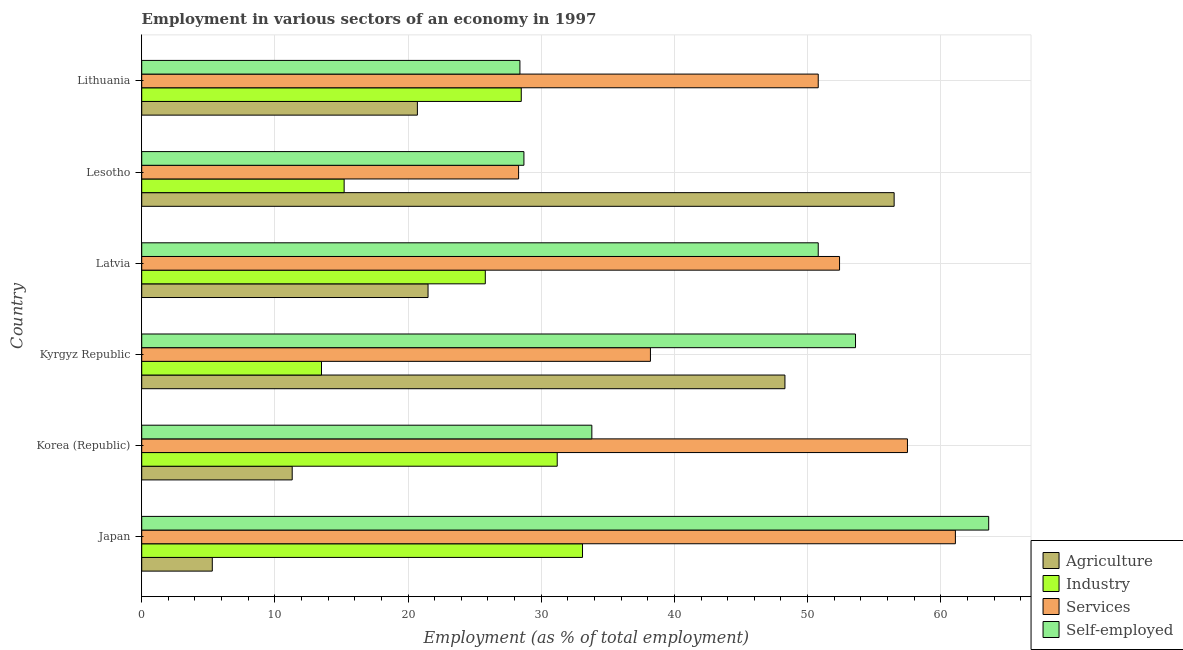How many different coloured bars are there?
Your answer should be very brief. 4. How many groups of bars are there?
Offer a very short reply. 6. Are the number of bars per tick equal to the number of legend labels?
Provide a short and direct response. Yes. Are the number of bars on each tick of the Y-axis equal?
Ensure brevity in your answer.  Yes. How many bars are there on the 6th tick from the top?
Ensure brevity in your answer.  4. What is the label of the 3rd group of bars from the top?
Your answer should be compact. Latvia. What is the percentage of self employed workers in Kyrgyz Republic?
Ensure brevity in your answer.  53.6. Across all countries, what is the maximum percentage of workers in services?
Your answer should be compact. 61.1. Across all countries, what is the minimum percentage of workers in agriculture?
Ensure brevity in your answer.  5.3. In which country was the percentage of self employed workers minimum?
Your answer should be very brief. Lithuania. What is the total percentage of workers in industry in the graph?
Ensure brevity in your answer.  147.3. What is the difference between the percentage of workers in industry in Japan and that in Kyrgyz Republic?
Ensure brevity in your answer.  19.6. What is the difference between the percentage of self employed workers in Lithuania and the percentage of workers in agriculture in Lesotho?
Give a very brief answer. -28.1. What is the average percentage of workers in agriculture per country?
Make the answer very short. 27.27. What is the difference between the percentage of workers in industry and percentage of self employed workers in Latvia?
Make the answer very short. -25. What is the ratio of the percentage of workers in industry in Latvia to that in Lithuania?
Offer a very short reply. 0.91. What is the difference between the highest and the lowest percentage of self employed workers?
Keep it short and to the point. 35.2. Is the sum of the percentage of workers in agriculture in Korea (Republic) and Kyrgyz Republic greater than the maximum percentage of workers in industry across all countries?
Offer a terse response. Yes. What does the 3rd bar from the top in Japan represents?
Your answer should be very brief. Industry. What does the 2nd bar from the bottom in Latvia represents?
Offer a terse response. Industry. Is it the case that in every country, the sum of the percentage of workers in agriculture and percentage of workers in industry is greater than the percentage of workers in services?
Ensure brevity in your answer.  No. How many bars are there?
Your response must be concise. 24. Are all the bars in the graph horizontal?
Offer a very short reply. Yes. How many countries are there in the graph?
Your answer should be compact. 6. Are the values on the major ticks of X-axis written in scientific E-notation?
Your response must be concise. No. Does the graph contain any zero values?
Ensure brevity in your answer.  No. Does the graph contain grids?
Keep it short and to the point. Yes. How many legend labels are there?
Make the answer very short. 4. How are the legend labels stacked?
Ensure brevity in your answer.  Vertical. What is the title of the graph?
Ensure brevity in your answer.  Employment in various sectors of an economy in 1997. What is the label or title of the X-axis?
Your answer should be very brief. Employment (as % of total employment). What is the label or title of the Y-axis?
Provide a succinct answer. Country. What is the Employment (as % of total employment) of Agriculture in Japan?
Give a very brief answer. 5.3. What is the Employment (as % of total employment) of Industry in Japan?
Offer a very short reply. 33.1. What is the Employment (as % of total employment) of Services in Japan?
Give a very brief answer. 61.1. What is the Employment (as % of total employment) in Self-employed in Japan?
Provide a succinct answer. 63.6. What is the Employment (as % of total employment) of Agriculture in Korea (Republic)?
Your answer should be very brief. 11.3. What is the Employment (as % of total employment) of Industry in Korea (Republic)?
Offer a terse response. 31.2. What is the Employment (as % of total employment) of Services in Korea (Republic)?
Make the answer very short. 57.5. What is the Employment (as % of total employment) of Self-employed in Korea (Republic)?
Give a very brief answer. 33.8. What is the Employment (as % of total employment) in Agriculture in Kyrgyz Republic?
Provide a short and direct response. 48.3. What is the Employment (as % of total employment) in Services in Kyrgyz Republic?
Your answer should be very brief. 38.2. What is the Employment (as % of total employment) in Self-employed in Kyrgyz Republic?
Offer a terse response. 53.6. What is the Employment (as % of total employment) of Agriculture in Latvia?
Ensure brevity in your answer.  21.5. What is the Employment (as % of total employment) of Industry in Latvia?
Give a very brief answer. 25.8. What is the Employment (as % of total employment) in Services in Latvia?
Keep it short and to the point. 52.4. What is the Employment (as % of total employment) of Self-employed in Latvia?
Offer a very short reply. 50.8. What is the Employment (as % of total employment) of Agriculture in Lesotho?
Provide a short and direct response. 56.5. What is the Employment (as % of total employment) of Industry in Lesotho?
Your response must be concise. 15.2. What is the Employment (as % of total employment) of Services in Lesotho?
Your answer should be very brief. 28.3. What is the Employment (as % of total employment) of Self-employed in Lesotho?
Ensure brevity in your answer.  28.7. What is the Employment (as % of total employment) in Agriculture in Lithuania?
Ensure brevity in your answer.  20.7. What is the Employment (as % of total employment) of Industry in Lithuania?
Your answer should be compact. 28.5. What is the Employment (as % of total employment) in Services in Lithuania?
Your answer should be compact. 50.8. What is the Employment (as % of total employment) of Self-employed in Lithuania?
Make the answer very short. 28.4. Across all countries, what is the maximum Employment (as % of total employment) of Agriculture?
Your answer should be compact. 56.5. Across all countries, what is the maximum Employment (as % of total employment) of Industry?
Make the answer very short. 33.1. Across all countries, what is the maximum Employment (as % of total employment) of Services?
Offer a terse response. 61.1. Across all countries, what is the maximum Employment (as % of total employment) of Self-employed?
Offer a very short reply. 63.6. Across all countries, what is the minimum Employment (as % of total employment) in Agriculture?
Your response must be concise. 5.3. Across all countries, what is the minimum Employment (as % of total employment) of Industry?
Ensure brevity in your answer.  13.5. Across all countries, what is the minimum Employment (as % of total employment) of Services?
Your answer should be very brief. 28.3. Across all countries, what is the minimum Employment (as % of total employment) in Self-employed?
Provide a short and direct response. 28.4. What is the total Employment (as % of total employment) in Agriculture in the graph?
Provide a succinct answer. 163.6. What is the total Employment (as % of total employment) in Industry in the graph?
Provide a succinct answer. 147.3. What is the total Employment (as % of total employment) in Services in the graph?
Provide a short and direct response. 288.3. What is the total Employment (as % of total employment) of Self-employed in the graph?
Make the answer very short. 258.9. What is the difference between the Employment (as % of total employment) of Agriculture in Japan and that in Korea (Republic)?
Give a very brief answer. -6. What is the difference between the Employment (as % of total employment) of Self-employed in Japan and that in Korea (Republic)?
Offer a terse response. 29.8. What is the difference between the Employment (as % of total employment) in Agriculture in Japan and that in Kyrgyz Republic?
Keep it short and to the point. -43. What is the difference between the Employment (as % of total employment) of Industry in Japan and that in Kyrgyz Republic?
Keep it short and to the point. 19.6. What is the difference between the Employment (as % of total employment) of Services in Japan and that in Kyrgyz Republic?
Ensure brevity in your answer.  22.9. What is the difference between the Employment (as % of total employment) in Self-employed in Japan and that in Kyrgyz Republic?
Offer a very short reply. 10. What is the difference between the Employment (as % of total employment) of Agriculture in Japan and that in Latvia?
Offer a very short reply. -16.2. What is the difference between the Employment (as % of total employment) of Industry in Japan and that in Latvia?
Offer a very short reply. 7.3. What is the difference between the Employment (as % of total employment) of Agriculture in Japan and that in Lesotho?
Make the answer very short. -51.2. What is the difference between the Employment (as % of total employment) in Services in Japan and that in Lesotho?
Your response must be concise. 32.8. What is the difference between the Employment (as % of total employment) in Self-employed in Japan and that in Lesotho?
Your response must be concise. 34.9. What is the difference between the Employment (as % of total employment) of Agriculture in Japan and that in Lithuania?
Your answer should be very brief. -15.4. What is the difference between the Employment (as % of total employment) of Industry in Japan and that in Lithuania?
Your response must be concise. 4.6. What is the difference between the Employment (as % of total employment) of Self-employed in Japan and that in Lithuania?
Provide a succinct answer. 35.2. What is the difference between the Employment (as % of total employment) of Agriculture in Korea (Republic) and that in Kyrgyz Republic?
Provide a succinct answer. -37. What is the difference between the Employment (as % of total employment) of Services in Korea (Republic) and that in Kyrgyz Republic?
Your answer should be compact. 19.3. What is the difference between the Employment (as % of total employment) of Self-employed in Korea (Republic) and that in Kyrgyz Republic?
Your answer should be very brief. -19.8. What is the difference between the Employment (as % of total employment) in Agriculture in Korea (Republic) and that in Latvia?
Give a very brief answer. -10.2. What is the difference between the Employment (as % of total employment) in Industry in Korea (Republic) and that in Latvia?
Provide a short and direct response. 5.4. What is the difference between the Employment (as % of total employment) of Services in Korea (Republic) and that in Latvia?
Offer a very short reply. 5.1. What is the difference between the Employment (as % of total employment) of Agriculture in Korea (Republic) and that in Lesotho?
Your response must be concise. -45.2. What is the difference between the Employment (as % of total employment) in Industry in Korea (Republic) and that in Lesotho?
Offer a very short reply. 16. What is the difference between the Employment (as % of total employment) in Services in Korea (Republic) and that in Lesotho?
Your response must be concise. 29.2. What is the difference between the Employment (as % of total employment) in Services in Korea (Republic) and that in Lithuania?
Provide a succinct answer. 6.7. What is the difference between the Employment (as % of total employment) of Agriculture in Kyrgyz Republic and that in Latvia?
Your answer should be very brief. 26.8. What is the difference between the Employment (as % of total employment) of Industry in Kyrgyz Republic and that in Latvia?
Offer a very short reply. -12.3. What is the difference between the Employment (as % of total employment) of Agriculture in Kyrgyz Republic and that in Lesotho?
Your answer should be compact. -8.2. What is the difference between the Employment (as % of total employment) of Services in Kyrgyz Republic and that in Lesotho?
Make the answer very short. 9.9. What is the difference between the Employment (as % of total employment) in Self-employed in Kyrgyz Republic and that in Lesotho?
Make the answer very short. 24.9. What is the difference between the Employment (as % of total employment) in Agriculture in Kyrgyz Republic and that in Lithuania?
Offer a terse response. 27.6. What is the difference between the Employment (as % of total employment) in Services in Kyrgyz Republic and that in Lithuania?
Keep it short and to the point. -12.6. What is the difference between the Employment (as % of total employment) of Self-employed in Kyrgyz Republic and that in Lithuania?
Ensure brevity in your answer.  25.2. What is the difference between the Employment (as % of total employment) in Agriculture in Latvia and that in Lesotho?
Provide a short and direct response. -35. What is the difference between the Employment (as % of total employment) of Services in Latvia and that in Lesotho?
Your answer should be compact. 24.1. What is the difference between the Employment (as % of total employment) in Self-employed in Latvia and that in Lesotho?
Provide a short and direct response. 22.1. What is the difference between the Employment (as % of total employment) of Self-employed in Latvia and that in Lithuania?
Make the answer very short. 22.4. What is the difference between the Employment (as % of total employment) in Agriculture in Lesotho and that in Lithuania?
Give a very brief answer. 35.8. What is the difference between the Employment (as % of total employment) of Industry in Lesotho and that in Lithuania?
Your answer should be compact. -13.3. What is the difference between the Employment (as % of total employment) in Services in Lesotho and that in Lithuania?
Provide a short and direct response. -22.5. What is the difference between the Employment (as % of total employment) of Self-employed in Lesotho and that in Lithuania?
Your answer should be very brief. 0.3. What is the difference between the Employment (as % of total employment) of Agriculture in Japan and the Employment (as % of total employment) of Industry in Korea (Republic)?
Give a very brief answer. -25.9. What is the difference between the Employment (as % of total employment) in Agriculture in Japan and the Employment (as % of total employment) in Services in Korea (Republic)?
Keep it short and to the point. -52.2. What is the difference between the Employment (as % of total employment) of Agriculture in Japan and the Employment (as % of total employment) of Self-employed in Korea (Republic)?
Provide a short and direct response. -28.5. What is the difference between the Employment (as % of total employment) of Industry in Japan and the Employment (as % of total employment) of Services in Korea (Republic)?
Your answer should be very brief. -24.4. What is the difference between the Employment (as % of total employment) of Services in Japan and the Employment (as % of total employment) of Self-employed in Korea (Republic)?
Keep it short and to the point. 27.3. What is the difference between the Employment (as % of total employment) in Agriculture in Japan and the Employment (as % of total employment) in Industry in Kyrgyz Republic?
Offer a terse response. -8.2. What is the difference between the Employment (as % of total employment) in Agriculture in Japan and the Employment (as % of total employment) in Services in Kyrgyz Republic?
Provide a short and direct response. -32.9. What is the difference between the Employment (as % of total employment) of Agriculture in Japan and the Employment (as % of total employment) of Self-employed in Kyrgyz Republic?
Your answer should be compact. -48.3. What is the difference between the Employment (as % of total employment) in Industry in Japan and the Employment (as % of total employment) in Self-employed in Kyrgyz Republic?
Your response must be concise. -20.5. What is the difference between the Employment (as % of total employment) of Agriculture in Japan and the Employment (as % of total employment) of Industry in Latvia?
Provide a succinct answer. -20.5. What is the difference between the Employment (as % of total employment) of Agriculture in Japan and the Employment (as % of total employment) of Services in Latvia?
Offer a terse response. -47.1. What is the difference between the Employment (as % of total employment) of Agriculture in Japan and the Employment (as % of total employment) of Self-employed in Latvia?
Make the answer very short. -45.5. What is the difference between the Employment (as % of total employment) of Industry in Japan and the Employment (as % of total employment) of Services in Latvia?
Offer a very short reply. -19.3. What is the difference between the Employment (as % of total employment) of Industry in Japan and the Employment (as % of total employment) of Self-employed in Latvia?
Ensure brevity in your answer.  -17.7. What is the difference between the Employment (as % of total employment) of Agriculture in Japan and the Employment (as % of total employment) of Services in Lesotho?
Make the answer very short. -23. What is the difference between the Employment (as % of total employment) in Agriculture in Japan and the Employment (as % of total employment) in Self-employed in Lesotho?
Ensure brevity in your answer.  -23.4. What is the difference between the Employment (as % of total employment) in Industry in Japan and the Employment (as % of total employment) in Self-employed in Lesotho?
Provide a succinct answer. 4.4. What is the difference between the Employment (as % of total employment) of Services in Japan and the Employment (as % of total employment) of Self-employed in Lesotho?
Provide a short and direct response. 32.4. What is the difference between the Employment (as % of total employment) in Agriculture in Japan and the Employment (as % of total employment) in Industry in Lithuania?
Offer a terse response. -23.2. What is the difference between the Employment (as % of total employment) in Agriculture in Japan and the Employment (as % of total employment) in Services in Lithuania?
Your answer should be compact. -45.5. What is the difference between the Employment (as % of total employment) in Agriculture in Japan and the Employment (as % of total employment) in Self-employed in Lithuania?
Offer a terse response. -23.1. What is the difference between the Employment (as % of total employment) of Industry in Japan and the Employment (as % of total employment) of Services in Lithuania?
Your answer should be very brief. -17.7. What is the difference between the Employment (as % of total employment) in Industry in Japan and the Employment (as % of total employment) in Self-employed in Lithuania?
Provide a succinct answer. 4.7. What is the difference between the Employment (as % of total employment) of Services in Japan and the Employment (as % of total employment) of Self-employed in Lithuania?
Your response must be concise. 32.7. What is the difference between the Employment (as % of total employment) of Agriculture in Korea (Republic) and the Employment (as % of total employment) of Services in Kyrgyz Republic?
Provide a short and direct response. -26.9. What is the difference between the Employment (as % of total employment) in Agriculture in Korea (Republic) and the Employment (as % of total employment) in Self-employed in Kyrgyz Republic?
Your response must be concise. -42.3. What is the difference between the Employment (as % of total employment) of Industry in Korea (Republic) and the Employment (as % of total employment) of Self-employed in Kyrgyz Republic?
Provide a short and direct response. -22.4. What is the difference between the Employment (as % of total employment) of Agriculture in Korea (Republic) and the Employment (as % of total employment) of Industry in Latvia?
Offer a terse response. -14.5. What is the difference between the Employment (as % of total employment) in Agriculture in Korea (Republic) and the Employment (as % of total employment) in Services in Latvia?
Provide a succinct answer. -41.1. What is the difference between the Employment (as % of total employment) in Agriculture in Korea (Republic) and the Employment (as % of total employment) in Self-employed in Latvia?
Provide a short and direct response. -39.5. What is the difference between the Employment (as % of total employment) of Industry in Korea (Republic) and the Employment (as % of total employment) of Services in Latvia?
Ensure brevity in your answer.  -21.2. What is the difference between the Employment (as % of total employment) in Industry in Korea (Republic) and the Employment (as % of total employment) in Self-employed in Latvia?
Keep it short and to the point. -19.6. What is the difference between the Employment (as % of total employment) of Agriculture in Korea (Republic) and the Employment (as % of total employment) of Services in Lesotho?
Your answer should be compact. -17. What is the difference between the Employment (as % of total employment) in Agriculture in Korea (Republic) and the Employment (as % of total employment) in Self-employed in Lesotho?
Your answer should be very brief. -17.4. What is the difference between the Employment (as % of total employment) in Industry in Korea (Republic) and the Employment (as % of total employment) in Self-employed in Lesotho?
Your answer should be compact. 2.5. What is the difference between the Employment (as % of total employment) in Services in Korea (Republic) and the Employment (as % of total employment) in Self-employed in Lesotho?
Provide a short and direct response. 28.8. What is the difference between the Employment (as % of total employment) of Agriculture in Korea (Republic) and the Employment (as % of total employment) of Industry in Lithuania?
Your response must be concise. -17.2. What is the difference between the Employment (as % of total employment) in Agriculture in Korea (Republic) and the Employment (as % of total employment) in Services in Lithuania?
Make the answer very short. -39.5. What is the difference between the Employment (as % of total employment) in Agriculture in Korea (Republic) and the Employment (as % of total employment) in Self-employed in Lithuania?
Keep it short and to the point. -17.1. What is the difference between the Employment (as % of total employment) of Industry in Korea (Republic) and the Employment (as % of total employment) of Services in Lithuania?
Your response must be concise. -19.6. What is the difference between the Employment (as % of total employment) of Industry in Korea (Republic) and the Employment (as % of total employment) of Self-employed in Lithuania?
Provide a succinct answer. 2.8. What is the difference between the Employment (as % of total employment) in Services in Korea (Republic) and the Employment (as % of total employment) in Self-employed in Lithuania?
Provide a short and direct response. 29.1. What is the difference between the Employment (as % of total employment) of Agriculture in Kyrgyz Republic and the Employment (as % of total employment) of Industry in Latvia?
Your answer should be compact. 22.5. What is the difference between the Employment (as % of total employment) in Agriculture in Kyrgyz Republic and the Employment (as % of total employment) in Self-employed in Latvia?
Make the answer very short. -2.5. What is the difference between the Employment (as % of total employment) of Industry in Kyrgyz Republic and the Employment (as % of total employment) of Services in Latvia?
Give a very brief answer. -38.9. What is the difference between the Employment (as % of total employment) of Industry in Kyrgyz Republic and the Employment (as % of total employment) of Self-employed in Latvia?
Provide a succinct answer. -37.3. What is the difference between the Employment (as % of total employment) of Agriculture in Kyrgyz Republic and the Employment (as % of total employment) of Industry in Lesotho?
Make the answer very short. 33.1. What is the difference between the Employment (as % of total employment) in Agriculture in Kyrgyz Republic and the Employment (as % of total employment) in Self-employed in Lesotho?
Your response must be concise. 19.6. What is the difference between the Employment (as % of total employment) of Industry in Kyrgyz Republic and the Employment (as % of total employment) of Services in Lesotho?
Offer a very short reply. -14.8. What is the difference between the Employment (as % of total employment) of Industry in Kyrgyz Republic and the Employment (as % of total employment) of Self-employed in Lesotho?
Your answer should be compact. -15.2. What is the difference between the Employment (as % of total employment) of Agriculture in Kyrgyz Republic and the Employment (as % of total employment) of Industry in Lithuania?
Make the answer very short. 19.8. What is the difference between the Employment (as % of total employment) of Agriculture in Kyrgyz Republic and the Employment (as % of total employment) of Services in Lithuania?
Keep it short and to the point. -2.5. What is the difference between the Employment (as % of total employment) of Agriculture in Kyrgyz Republic and the Employment (as % of total employment) of Self-employed in Lithuania?
Your answer should be very brief. 19.9. What is the difference between the Employment (as % of total employment) of Industry in Kyrgyz Republic and the Employment (as % of total employment) of Services in Lithuania?
Give a very brief answer. -37.3. What is the difference between the Employment (as % of total employment) in Industry in Kyrgyz Republic and the Employment (as % of total employment) in Self-employed in Lithuania?
Offer a very short reply. -14.9. What is the difference between the Employment (as % of total employment) in Agriculture in Latvia and the Employment (as % of total employment) in Services in Lesotho?
Provide a succinct answer. -6.8. What is the difference between the Employment (as % of total employment) of Agriculture in Latvia and the Employment (as % of total employment) of Self-employed in Lesotho?
Your answer should be compact. -7.2. What is the difference between the Employment (as % of total employment) of Industry in Latvia and the Employment (as % of total employment) of Services in Lesotho?
Your response must be concise. -2.5. What is the difference between the Employment (as % of total employment) of Industry in Latvia and the Employment (as % of total employment) of Self-employed in Lesotho?
Keep it short and to the point. -2.9. What is the difference between the Employment (as % of total employment) in Services in Latvia and the Employment (as % of total employment) in Self-employed in Lesotho?
Make the answer very short. 23.7. What is the difference between the Employment (as % of total employment) of Agriculture in Latvia and the Employment (as % of total employment) of Industry in Lithuania?
Offer a terse response. -7. What is the difference between the Employment (as % of total employment) in Agriculture in Latvia and the Employment (as % of total employment) in Services in Lithuania?
Your response must be concise. -29.3. What is the difference between the Employment (as % of total employment) in Agriculture in Latvia and the Employment (as % of total employment) in Self-employed in Lithuania?
Offer a terse response. -6.9. What is the difference between the Employment (as % of total employment) in Services in Latvia and the Employment (as % of total employment) in Self-employed in Lithuania?
Your answer should be compact. 24. What is the difference between the Employment (as % of total employment) of Agriculture in Lesotho and the Employment (as % of total employment) of Self-employed in Lithuania?
Your response must be concise. 28.1. What is the difference between the Employment (as % of total employment) in Industry in Lesotho and the Employment (as % of total employment) in Services in Lithuania?
Offer a very short reply. -35.6. What is the average Employment (as % of total employment) of Agriculture per country?
Keep it short and to the point. 27.27. What is the average Employment (as % of total employment) in Industry per country?
Offer a very short reply. 24.55. What is the average Employment (as % of total employment) of Services per country?
Give a very brief answer. 48.05. What is the average Employment (as % of total employment) in Self-employed per country?
Make the answer very short. 43.15. What is the difference between the Employment (as % of total employment) in Agriculture and Employment (as % of total employment) in Industry in Japan?
Provide a succinct answer. -27.8. What is the difference between the Employment (as % of total employment) of Agriculture and Employment (as % of total employment) of Services in Japan?
Your response must be concise. -55.8. What is the difference between the Employment (as % of total employment) in Agriculture and Employment (as % of total employment) in Self-employed in Japan?
Make the answer very short. -58.3. What is the difference between the Employment (as % of total employment) in Industry and Employment (as % of total employment) in Services in Japan?
Provide a short and direct response. -28. What is the difference between the Employment (as % of total employment) in Industry and Employment (as % of total employment) in Self-employed in Japan?
Keep it short and to the point. -30.5. What is the difference between the Employment (as % of total employment) in Services and Employment (as % of total employment) in Self-employed in Japan?
Provide a short and direct response. -2.5. What is the difference between the Employment (as % of total employment) of Agriculture and Employment (as % of total employment) of Industry in Korea (Republic)?
Keep it short and to the point. -19.9. What is the difference between the Employment (as % of total employment) of Agriculture and Employment (as % of total employment) of Services in Korea (Republic)?
Make the answer very short. -46.2. What is the difference between the Employment (as % of total employment) in Agriculture and Employment (as % of total employment) in Self-employed in Korea (Republic)?
Provide a succinct answer. -22.5. What is the difference between the Employment (as % of total employment) in Industry and Employment (as % of total employment) in Services in Korea (Republic)?
Provide a short and direct response. -26.3. What is the difference between the Employment (as % of total employment) of Industry and Employment (as % of total employment) of Self-employed in Korea (Republic)?
Your answer should be very brief. -2.6. What is the difference between the Employment (as % of total employment) of Services and Employment (as % of total employment) of Self-employed in Korea (Republic)?
Ensure brevity in your answer.  23.7. What is the difference between the Employment (as % of total employment) of Agriculture and Employment (as % of total employment) of Industry in Kyrgyz Republic?
Provide a short and direct response. 34.8. What is the difference between the Employment (as % of total employment) in Agriculture and Employment (as % of total employment) in Services in Kyrgyz Republic?
Your answer should be compact. 10.1. What is the difference between the Employment (as % of total employment) of Industry and Employment (as % of total employment) of Services in Kyrgyz Republic?
Provide a succinct answer. -24.7. What is the difference between the Employment (as % of total employment) of Industry and Employment (as % of total employment) of Self-employed in Kyrgyz Republic?
Ensure brevity in your answer.  -40.1. What is the difference between the Employment (as % of total employment) of Services and Employment (as % of total employment) of Self-employed in Kyrgyz Republic?
Make the answer very short. -15.4. What is the difference between the Employment (as % of total employment) in Agriculture and Employment (as % of total employment) in Industry in Latvia?
Provide a succinct answer. -4.3. What is the difference between the Employment (as % of total employment) of Agriculture and Employment (as % of total employment) of Services in Latvia?
Provide a short and direct response. -30.9. What is the difference between the Employment (as % of total employment) in Agriculture and Employment (as % of total employment) in Self-employed in Latvia?
Ensure brevity in your answer.  -29.3. What is the difference between the Employment (as % of total employment) in Industry and Employment (as % of total employment) in Services in Latvia?
Make the answer very short. -26.6. What is the difference between the Employment (as % of total employment) of Industry and Employment (as % of total employment) of Self-employed in Latvia?
Provide a succinct answer. -25. What is the difference between the Employment (as % of total employment) of Agriculture and Employment (as % of total employment) of Industry in Lesotho?
Give a very brief answer. 41.3. What is the difference between the Employment (as % of total employment) of Agriculture and Employment (as % of total employment) of Services in Lesotho?
Make the answer very short. 28.2. What is the difference between the Employment (as % of total employment) in Agriculture and Employment (as % of total employment) in Self-employed in Lesotho?
Ensure brevity in your answer.  27.8. What is the difference between the Employment (as % of total employment) of Industry and Employment (as % of total employment) of Services in Lesotho?
Keep it short and to the point. -13.1. What is the difference between the Employment (as % of total employment) in Industry and Employment (as % of total employment) in Self-employed in Lesotho?
Make the answer very short. -13.5. What is the difference between the Employment (as % of total employment) of Agriculture and Employment (as % of total employment) of Industry in Lithuania?
Provide a succinct answer. -7.8. What is the difference between the Employment (as % of total employment) of Agriculture and Employment (as % of total employment) of Services in Lithuania?
Ensure brevity in your answer.  -30.1. What is the difference between the Employment (as % of total employment) in Agriculture and Employment (as % of total employment) in Self-employed in Lithuania?
Make the answer very short. -7.7. What is the difference between the Employment (as % of total employment) in Industry and Employment (as % of total employment) in Services in Lithuania?
Provide a short and direct response. -22.3. What is the difference between the Employment (as % of total employment) in Industry and Employment (as % of total employment) in Self-employed in Lithuania?
Your response must be concise. 0.1. What is the difference between the Employment (as % of total employment) in Services and Employment (as % of total employment) in Self-employed in Lithuania?
Offer a terse response. 22.4. What is the ratio of the Employment (as % of total employment) in Agriculture in Japan to that in Korea (Republic)?
Offer a terse response. 0.47. What is the ratio of the Employment (as % of total employment) of Industry in Japan to that in Korea (Republic)?
Keep it short and to the point. 1.06. What is the ratio of the Employment (as % of total employment) of Services in Japan to that in Korea (Republic)?
Keep it short and to the point. 1.06. What is the ratio of the Employment (as % of total employment) in Self-employed in Japan to that in Korea (Republic)?
Your answer should be compact. 1.88. What is the ratio of the Employment (as % of total employment) in Agriculture in Japan to that in Kyrgyz Republic?
Provide a succinct answer. 0.11. What is the ratio of the Employment (as % of total employment) of Industry in Japan to that in Kyrgyz Republic?
Offer a very short reply. 2.45. What is the ratio of the Employment (as % of total employment) of Services in Japan to that in Kyrgyz Republic?
Make the answer very short. 1.6. What is the ratio of the Employment (as % of total employment) of Self-employed in Japan to that in Kyrgyz Republic?
Offer a terse response. 1.19. What is the ratio of the Employment (as % of total employment) of Agriculture in Japan to that in Latvia?
Offer a terse response. 0.25. What is the ratio of the Employment (as % of total employment) of Industry in Japan to that in Latvia?
Provide a short and direct response. 1.28. What is the ratio of the Employment (as % of total employment) of Services in Japan to that in Latvia?
Your answer should be compact. 1.17. What is the ratio of the Employment (as % of total employment) in Self-employed in Japan to that in Latvia?
Ensure brevity in your answer.  1.25. What is the ratio of the Employment (as % of total employment) of Agriculture in Japan to that in Lesotho?
Your response must be concise. 0.09. What is the ratio of the Employment (as % of total employment) of Industry in Japan to that in Lesotho?
Keep it short and to the point. 2.18. What is the ratio of the Employment (as % of total employment) of Services in Japan to that in Lesotho?
Offer a terse response. 2.16. What is the ratio of the Employment (as % of total employment) of Self-employed in Japan to that in Lesotho?
Keep it short and to the point. 2.22. What is the ratio of the Employment (as % of total employment) in Agriculture in Japan to that in Lithuania?
Provide a short and direct response. 0.26. What is the ratio of the Employment (as % of total employment) in Industry in Japan to that in Lithuania?
Ensure brevity in your answer.  1.16. What is the ratio of the Employment (as % of total employment) in Services in Japan to that in Lithuania?
Keep it short and to the point. 1.2. What is the ratio of the Employment (as % of total employment) in Self-employed in Japan to that in Lithuania?
Your answer should be very brief. 2.24. What is the ratio of the Employment (as % of total employment) in Agriculture in Korea (Republic) to that in Kyrgyz Republic?
Offer a very short reply. 0.23. What is the ratio of the Employment (as % of total employment) in Industry in Korea (Republic) to that in Kyrgyz Republic?
Keep it short and to the point. 2.31. What is the ratio of the Employment (as % of total employment) of Services in Korea (Republic) to that in Kyrgyz Republic?
Your answer should be very brief. 1.51. What is the ratio of the Employment (as % of total employment) in Self-employed in Korea (Republic) to that in Kyrgyz Republic?
Offer a very short reply. 0.63. What is the ratio of the Employment (as % of total employment) of Agriculture in Korea (Republic) to that in Latvia?
Give a very brief answer. 0.53. What is the ratio of the Employment (as % of total employment) in Industry in Korea (Republic) to that in Latvia?
Your answer should be very brief. 1.21. What is the ratio of the Employment (as % of total employment) in Services in Korea (Republic) to that in Latvia?
Your answer should be compact. 1.1. What is the ratio of the Employment (as % of total employment) of Self-employed in Korea (Republic) to that in Latvia?
Your response must be concise. 0.67. What is the ratio of the Employment (as % of total employment) of Agriculture in Korea (Republic) to that in Lesotho?
Your response must be concise. 0.2. What is the ratio of the Employment (as % of total employment) of Industry in Korea (Republic) to that in Lesotho?
Ensure brevity in your answer.  2.05. What is the ratio of the Employment (as % of total employment) of Services in Korea (Republic) to that in Lesotho?
Offer a terse response. 2.03. What is the ratio of the Employment (as % of total employment) in Self-employed in Korea (Republic) to that in Lesotho?
Give a very brief answer. 1.18. What is the ratio of the Employment (as % of total employment) of Agriculture in Korea (Republic) to that in Lithuania?
Offer a terse response. 0.55. What is the ratio of the Employment (as % of total employment) in Industry in Korea (Republic) to that in Lithuania?
Give a very brief answer. 1.09. What is the ratio of the Employment (as % of total employment) in Services in Korea (Republic) to that in Lithuania?
Offer a terse response. 1.13. What is the ratio of the Employment (as % of total employment) in Self-employed in Korea (Republic) to that in Lithuania?
Give a very brief answer. 1.19. What is the ratio of the Employment (as % of total employment) in Agriculture in Kyrgyz Republic to that in Latvia?
Your answer should be compact. 2.25. What is the ratio of the Employment (as % of total employment) of Industry in Kyrgyz Republic to that in Latvia?
Offer a terse response. 0.52. What is the ratio of the Employment (as % of total employment) in Services in Kyrgyz Republic to that in Latvia?
Keep it short and to the point. 0.73. What is the ratio of the Employment (as % of total employment) of Self-employed in Kyrgyz Republic to that in Latvia?
Ensure brevity in your answer.  1.06. What is the ratio of the Employment (as % of total employment) in Agriculture in Kyrgyz Republic to that in Lesotho?
Your response must be concise. 0.85. What is the ratio of the Employment (as % of total employment) in Industry in Kyrgyz Republic to that in Lesotho?
Offer a terse response. 0.89. What is the ratio of the Employment (as % of total employment) of Services in Kyrgyz Republic to that in Lesotho?
Your response must be concise. 1.35. What is the ratio of the Employment (as % of total employment) of Self-employed in Kyrgyz Republic to that in Lesotho?
Your answer should be very brief. 1.87. What is the ratio of the Employment (as % of total employment) of Agriculture in Kyrgyz Republic to that in Lithuania?
Make the answer very short. 2.33. What is the ratio of the Employment (as % of total employment) of Industry in Kyrgyz Republic to that in Lithuania?
Your answer should be compact. 0.47. What is the ratio of the Employment (as % of total employment) of Services in Kyrgyz Republic to that in Lithuania?
Your answer should be very brief. 0.75. What is the ratio of the Employment (as % of total employment) of Self-employed in Kyrgyz Republic to that in Lithuania?
Offer a terse response. 1.89. What is the ratio of the Employment (as % of total employment) in Agriculture in Latvia to that in Lesotho?
Your answer should be compact. 0.38. What is the ratio of the Employment (as % of total employment) in Industry in Latvia to that in Lesotho?
Keep it short and to the point. 1.7. What is the ratio of the Employment (as % of total employment) of Services in Latvia to that in Lesotho?
Ensure brevity in your answer.  1.85. What is the ratio of the Employment (as % of total employment) in Self-employed in Latvia to that in Lesotho?
Keep it short and to the point. 1.77. What is the ratio of the Employment (as % of total employment) of Agriculture in Latvia to that in Lithuania?
Your answer should be very brief. 1.04. What is the ratio of the Employment (as % of total employment) in Industry in Latvia to that in Lithuania?
Provide a short and direct response. 0.91. What is the ratio of the Employment (as % of total employment) in Services in Latvia to that in Lithuania?
Your answer should be very brief. 1.03. What is the ratio of the Employment (as % of total employment) in Self-employed in Latvia to that in Lithuania?
Your answer should be very brief. 1.79. What is the ratio of the Employment (as % of total employment) in Agriculture in Lesotho to that in Lithuania?
Give a very brief answer. 2.73. What is the ratio of the Employment (as % of total employment) in Industry in Lesotho to that in Lithuania?
Provide a short and direct response. 0.53. What is the ratio of the Employment (as % of total employment) of Services in Lesotho to that in Lithuania?
Offer a very short reply. 0.56. What is the ratio of the Employment (as % of total employment) in Self-employed in Lesotho to that in Lithuania?
Your response must be concise. 1.01. What is the difference between the highest and the second highest Employment (as % of total employment) in Agriculture?
Keep it short and to the point. 8.2. What is the difference between the highest and the second highest Employment (as % of total employment) in Self-employed?
Keep it short and to the point. 10. What is the difference between the highest and the lowest Employment (as % of total employment) of Agriculture?
Give a very brief answer. 51.2. What is the difference between the highest and the lowest Employment (as % of total employment) of Industry?
Keep it short and to the point. 19.6. What is the difference between the highest and the lowest Employment (as % of total employment) of Services?
Provide a short and direct response. 32.8. What is the difference between the highest and the lowest Employment (as % of total employment) in Self-employed?
Keep it short and to the point. 35.2. 